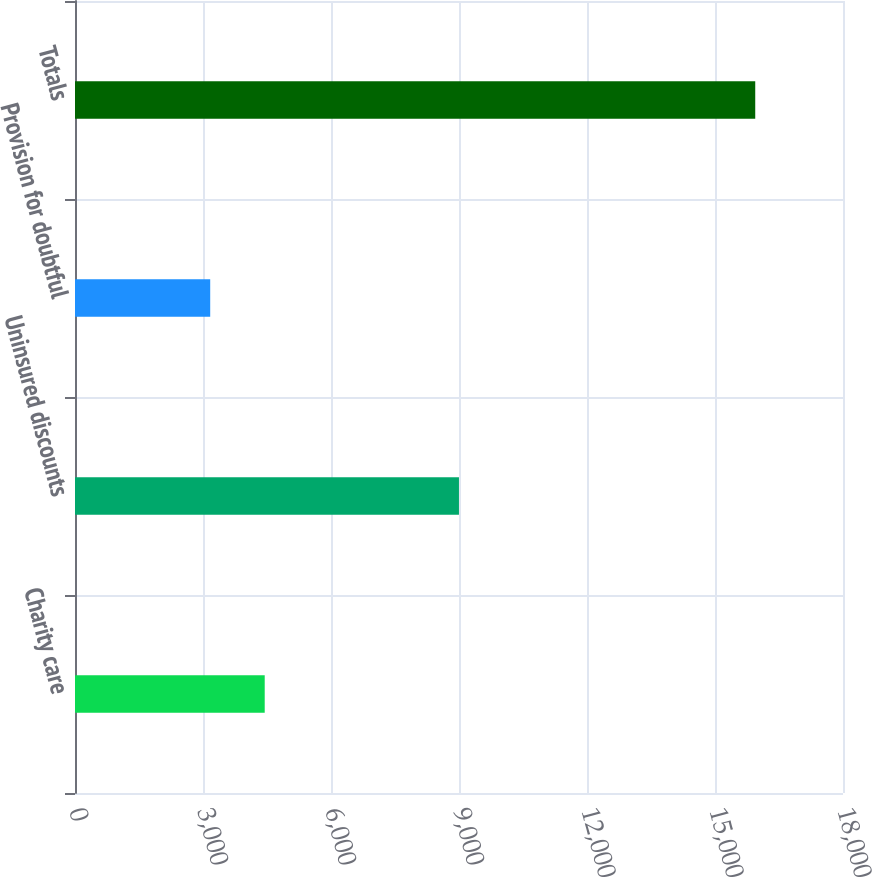Convert chart to OTSL. <chart><loc_0><loc_0><loc_500><loc_500><bar_chart><fcel>Charity care<fcel>Uninsured discounts<fcel>Provision for doubtful<fcel>Totals<nl><fcel>4446.4<fcel>8999<fcel>3169<fcel>15943<nl></chart> 